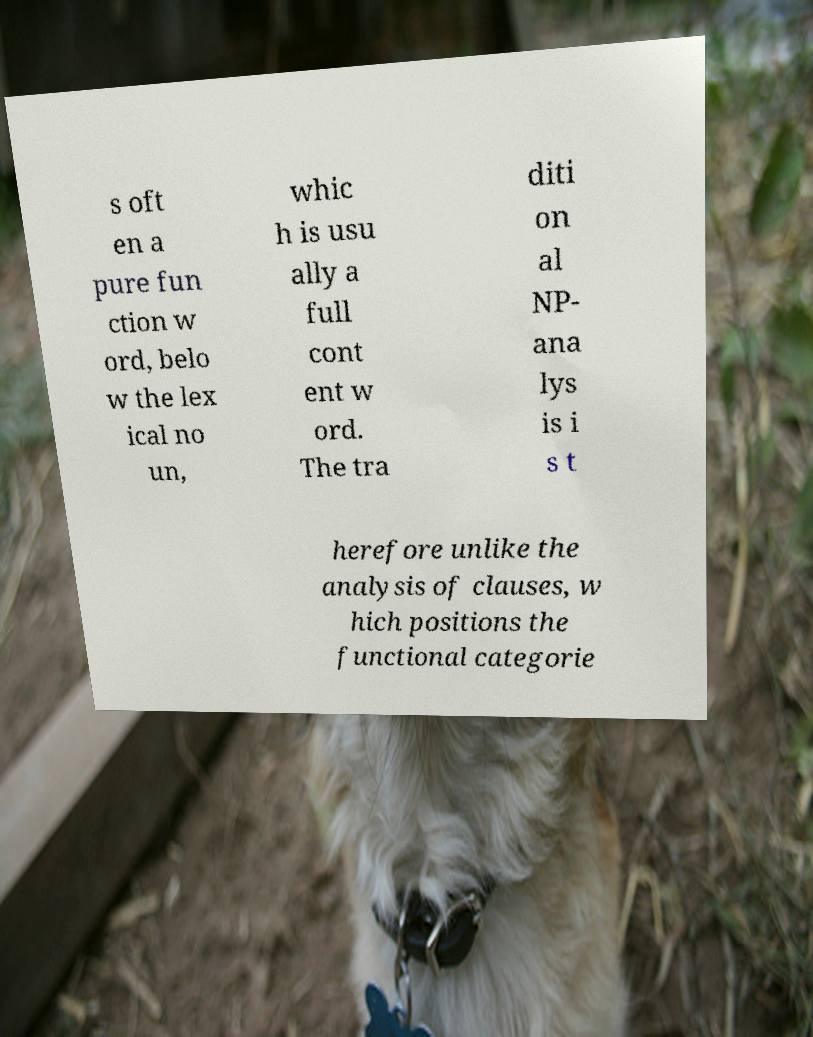Could you extract and type out the text from this image? s oft en a pure fun ction w ord, belo w the lex ical no un, whic h is usu ally a full cont ent w ord. The tra diti on al NP- ana lys is i s t herefore unlike the analysis of clauses, w hich positions the functional categorie 